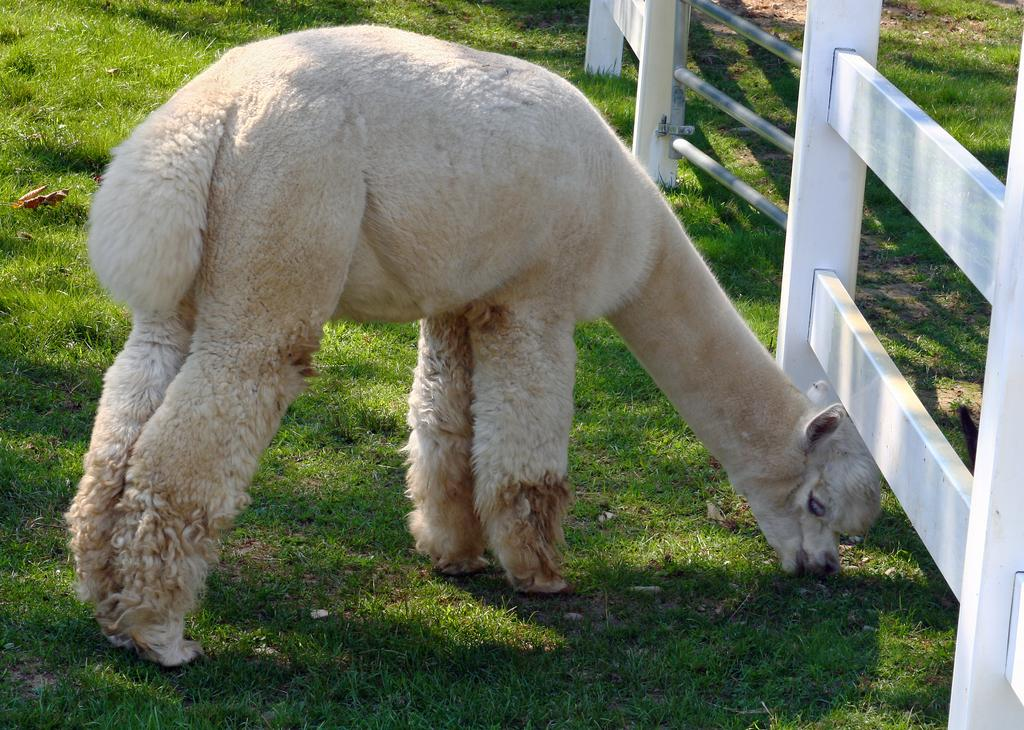What type of animal is in the image? The type of animal cannot be determined from the provided facts. Where is the animal located in the image? The animal is on a grass field. What is the purpose of the fence in the image? The purpose of the fence cannot be determined from the provided facts. What type of magic spell is being cast by the animal in the image? There is no indication of magic or a spell being cast in the image. What type of loaf is being used as a prop in the image? There is no loaf present in the image. 